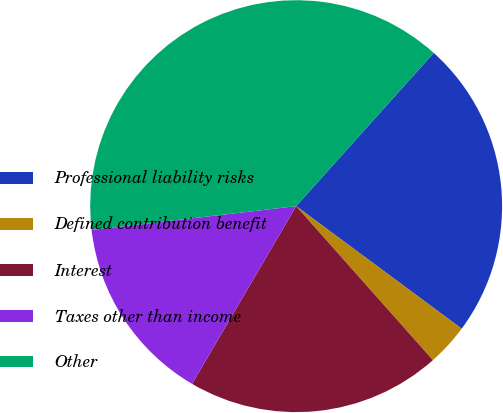Convert chart to OTSL. <chart><loc_0><loc_0><loc_500><loc_500><pie_chart><fcel>Professional liability risks<fcel>Defined contribution benefit<fcel>Interest<fcel>Taxes other than income<fcel>Other<nl><fcel>23.5%<fcel>3.3%<fcel>19.99%<fcel>14.72%<fcel>38.49%<nl></chart> 